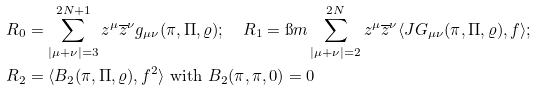Convert formula to latex. <formula><loc_0><loc_0><loc_500><loc_500>& { R _ { 0 } } = \sum _ { | \mu + \nu | = 3 } ^ { 2 { N } + 1 } z ^ { \mu } \overline { z } ^ { \nu } g _ { \mu \nu } ( \pi , \Pi , \varrho ) ; \quad R _ { 1 } = \i m \sum _ { | \mu + \nu | = 2 } ^ { 2 { N } } z ^ { \mu } \overline { z } ^ { \nu } \langle J G _ { \mu \nu } ( \pi , \Pi , \varrho ) , f \rangle ; \\ & { R _ { 2 } } = \langle B _ { 2 } ( \pi , \Pi , \varrho ) , f ^ { 2 } \rangle \text { with $B_{2 } (\pi , \pi , 0)=0$}</formula> 